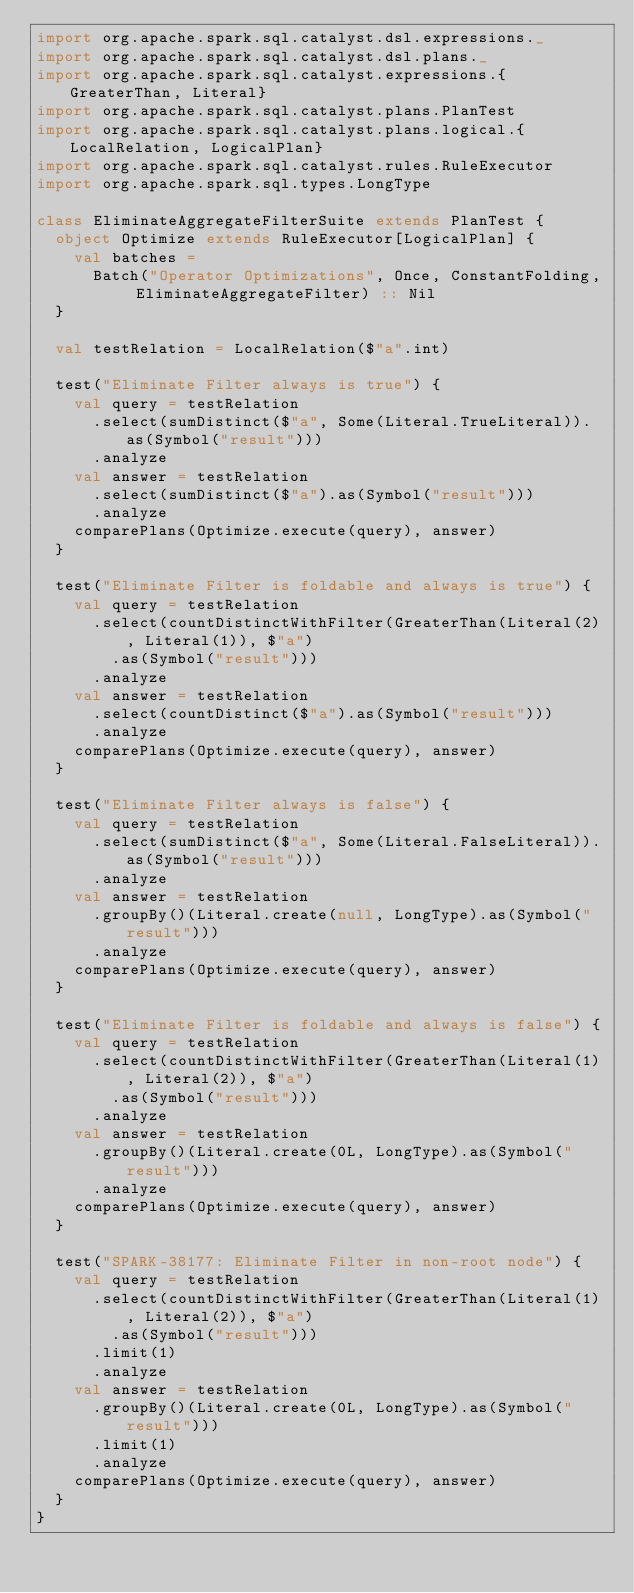<code> <loc_0><loc_0><loc_500><loc_500><_Scala_>import org.apache.spark.sql.catalyst.dsl.expressions._
import org.apache.spark.sql.catalyst.dsl.plans._
import org.apache.spark.sql.catalyst.expressions.{GreaterThan, Literal}
import org.apache.spark.sql.catalyst.plans.PlanTest
import org.apache.spark.sql.catalyst.plans.logical.{LocalRelation, LogicalPlan}
import org.apache.spark.sql.catalyst.rules.RuleExecutor
import org.apache.spark.sql.types.LongType

class EliminateAggregateFilterSuite extends PlanTest {
  object Optimize extends RuleExecutor[LogicalPlan] {
    val batches =
      Batch("Operator Optimizations", Once, ConstantFolding, EliminateAggregateFilter) :: Nil
  }

  val testRelation = LocalRelation($"a".int)

  test("Eliminate Filter always is true") {
    val query = testRelation
      .select(sumDistinct($"a", Some(Literal.TrueLiteral)).as(Symbol("result")))
      .analyze
    val answer = testRelation
      .select(sumDistinct($"a").as(Symbol("result")))
      .analyze
    comparePlans(Optimize.execute(query), answer)
  }

  test("Eliminate Filter is foldable and always is true") {
    val query = testRelation
      .select(countDistinctWithFilter(GreaterThan(Literal(2), Literal(1)), $"a")
        .as(Symbol("result")))
      .analyze
    val answer = testRelation
      .select(countDistinct($"a").as(Symbol("result")))
      .analyze
    comparePlans(Optimize.execute(query), answer)
  }

  test("Eliminate Filter always is false") {
    val query = testRelation
      .select(sumDistinct($"a", Some(Literal.FalseLiteral)).as(Symbol("result")))
      .analyze
    val answer = testRelation
      .groupBy()(Literal.create(null, LongType).as(Symbol("result")))
      .analyze
    comparePlans(Optimize.execute(query), answer)
  }

  test("Eliminate Filter is foldable and always is false") {
    val query = testRelation
      .select(countDistinctWithFilter(GreaterThan(Literal(1), Literal(2)), $"a")
        .as(Symbol("result")))
      .analyze
    val answer = testRelation
      .groupBy()(Literal.create(0L, LongType).as(Symbol("result")))
      .analyze
    comparePlans(Optimize.execute(query), answer)
  }

  test("SPARK-38177: Eliminate Filter in non-root node") {
    val query = testRelation
      .select(countDistinctWithFilter(GreaterThan(Literal(1), Literal(2)), $"a")
        .as(Symbol("result")))
      .limit(1)
      .analyze
    val answer = testRelation
      .groupBy()(Literal.create(0L, LongType).as(Symbol("result")))
      .limit(1)
      .analyze
    comparePlans(Optimize.execute(query), answer)
  }
}
</code> 